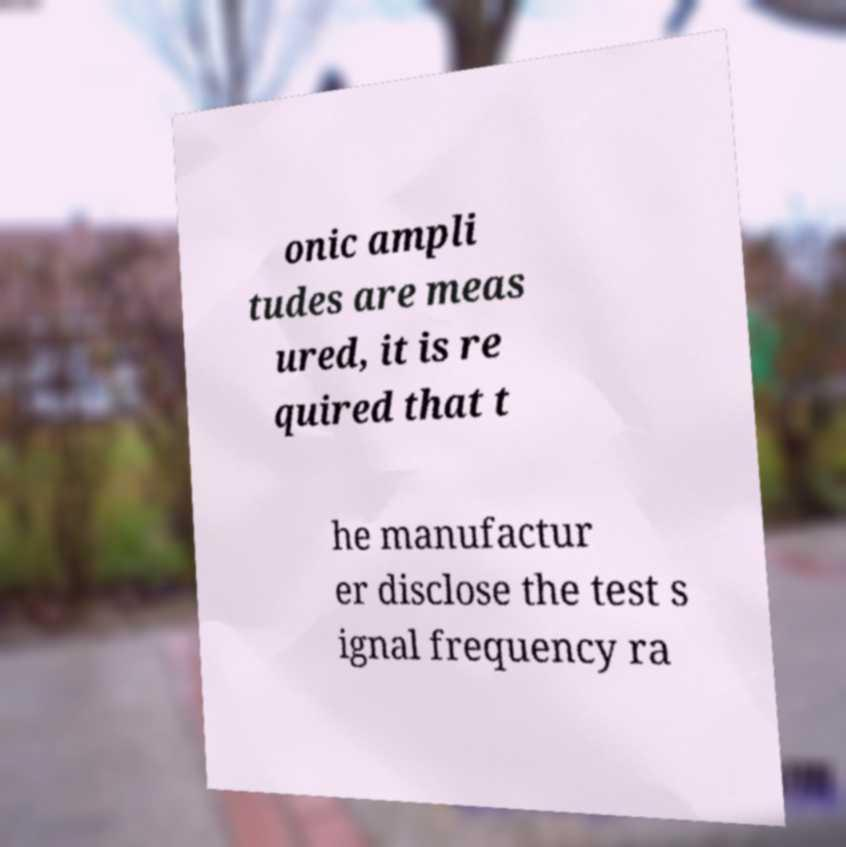I need the written content from this picture converted into text. Can you do that? onic ampli tudes are meas ured, it is re quired that t he manufactur er disclose the test s ignal frequency ra 